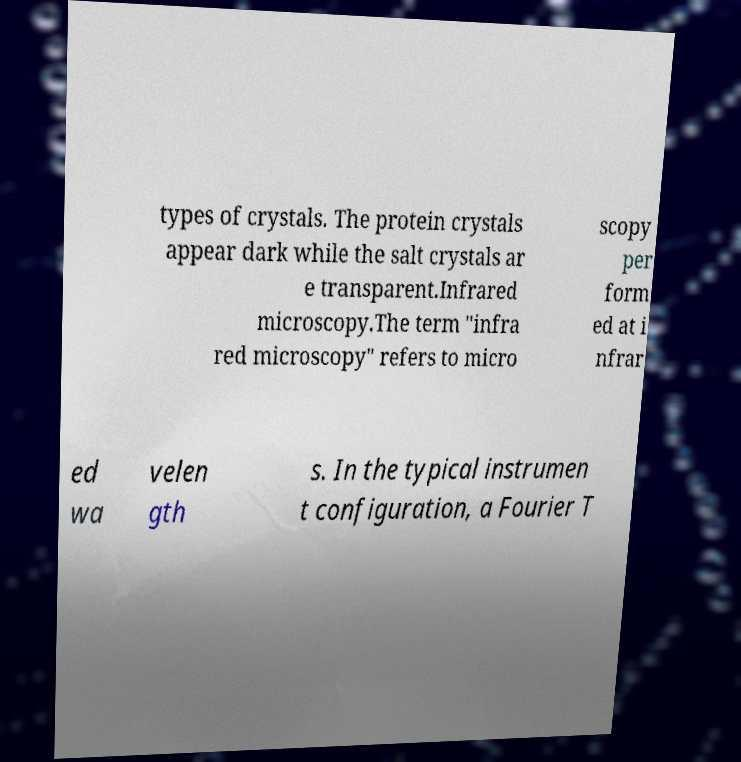There's text embedded in this image that I need extracted. Can you transcribe it verbatim? types of crystals. The protein crystals appear dark while the salt crystals ar e transparent.Infrared microscopy.The term "infra red microscopy" refers to micro scopy per form ed at i nfrar ed wa velen gth s. In the typical instrumen t configuration, a Fourier T 